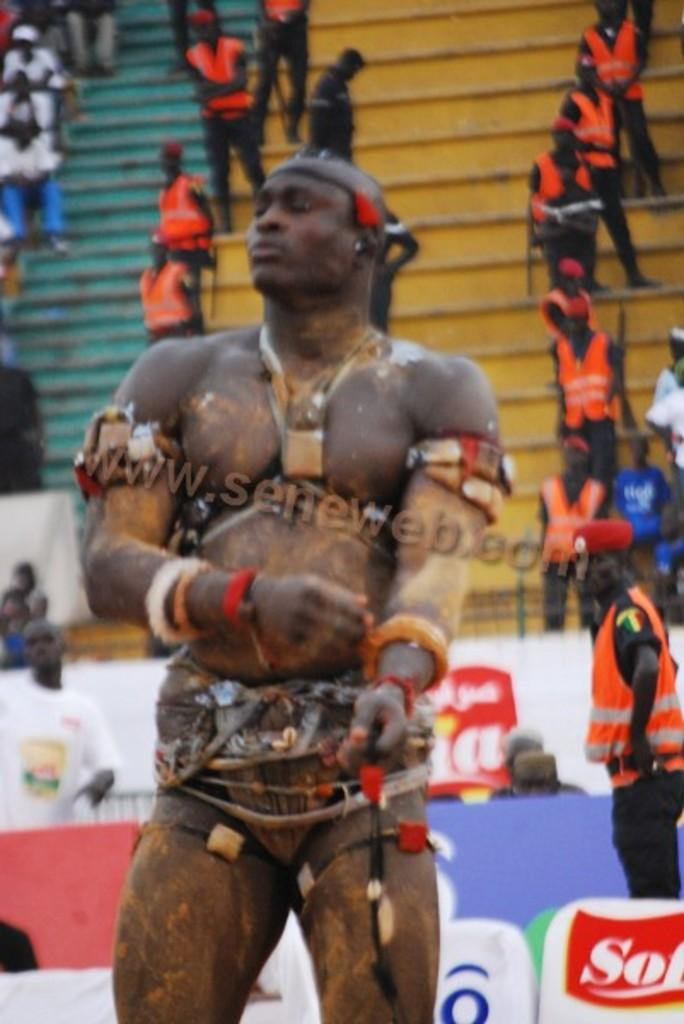What is the main subject of the image? There is a person standing in the image. What can be seen behind the person? There are sponsor boards behind the person. What else is visible in the background of the image? There are people standing in the stands behind the sponsor boards. How many legs does the balloon have in the image? There is no balloon present in the image. What role does the actor play in the image? There is no actor present in the image. 